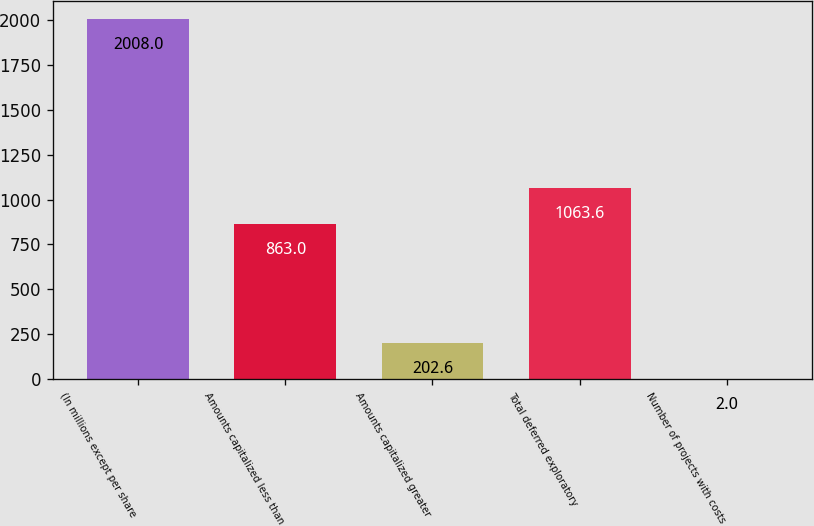Convert chart. <chart><loc_0><loc_0><loc_500><loc_500><bar_chart><fcel>(In millions except per share<fcel>Amounts capitalized less than<fcel>Amounts capitalized greater<fcel>Total deferred exploratory<fcel>Number of projects with costs<nl><fcel>2008<fcel>863<fcel>202.6<fcel>1063.6<fcel>2<nl></chart> 